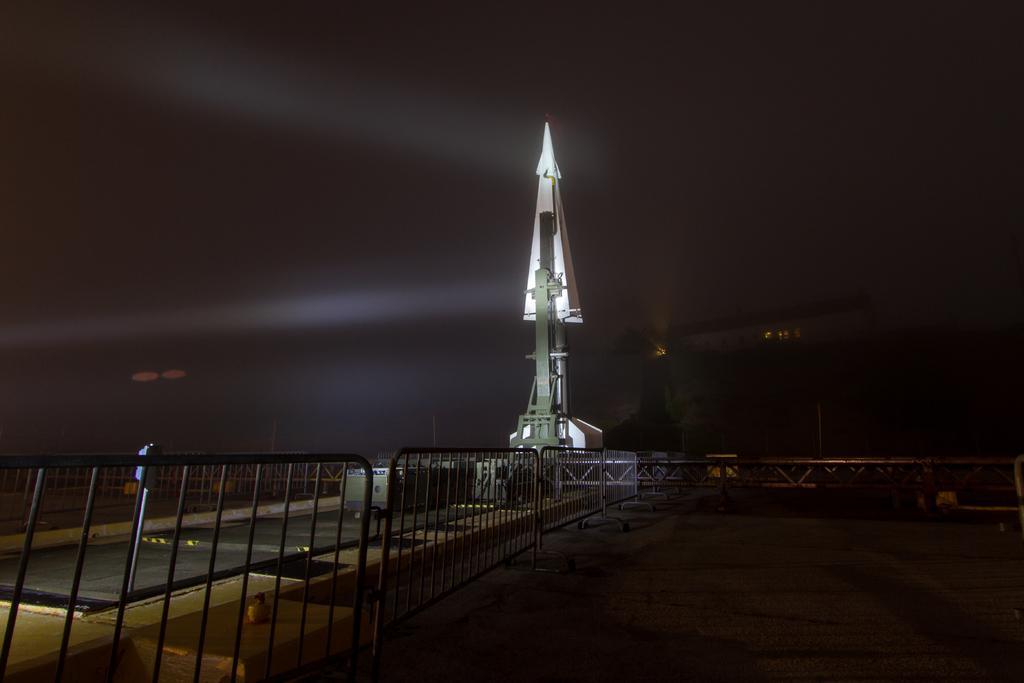Can you describe this image briefly? In this image we can see a rocket. There is a fencing in the image. 